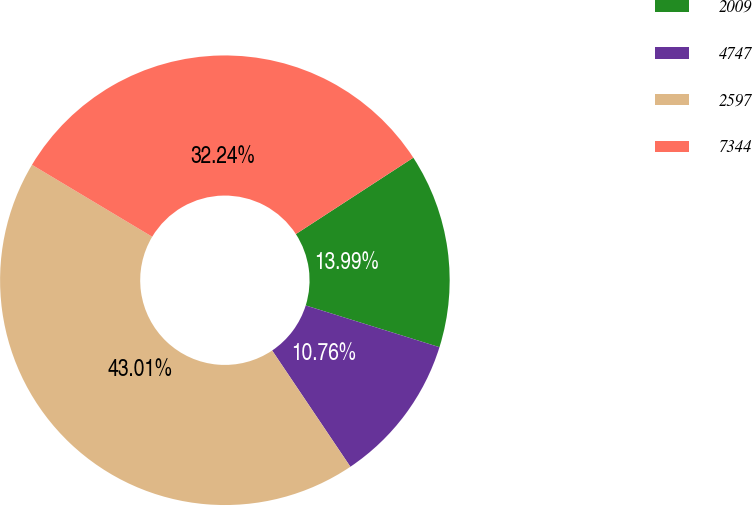Convert chart to OTSL. <chart><loc_0><loc_0><loc_500><loc_500><pie_chart><fcel>2009<fcel>4747<fcel>2597<fcel>7344<nl><fcel>13.99%<fcel>10.76%<fcel>43.01%<fcel>32.24%<nl></chart> 